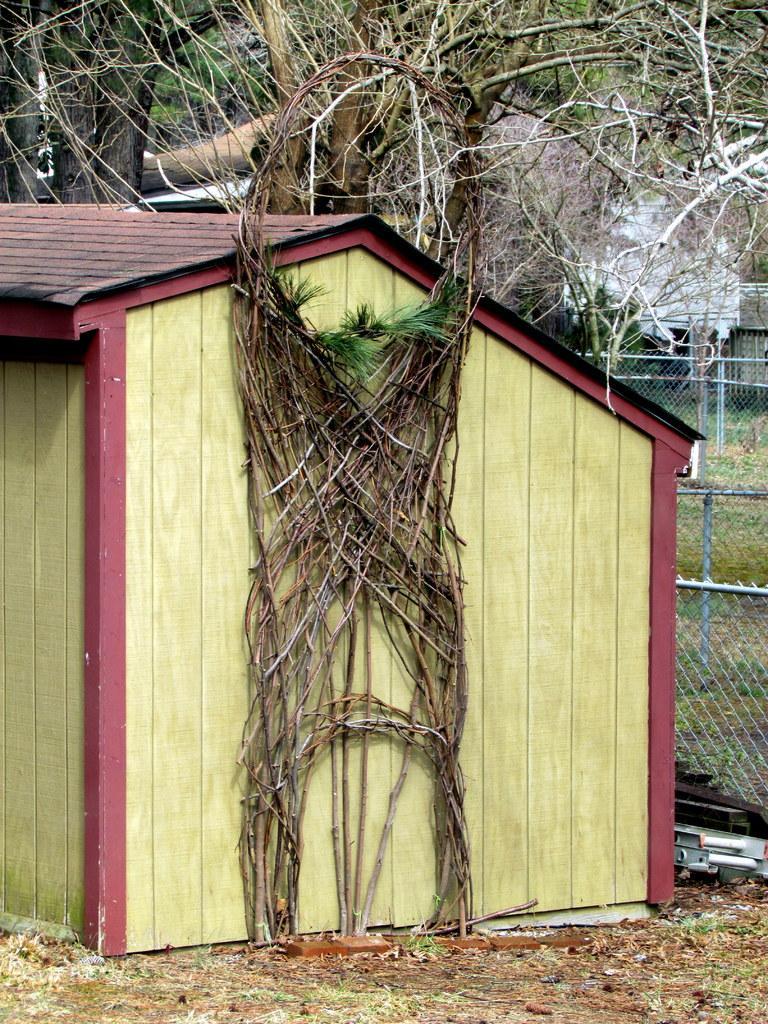Could you give a brief overview of what you see in this image? In the center of the image there is a shed. In the background there are trees and fence. At the bottom there is grass. 